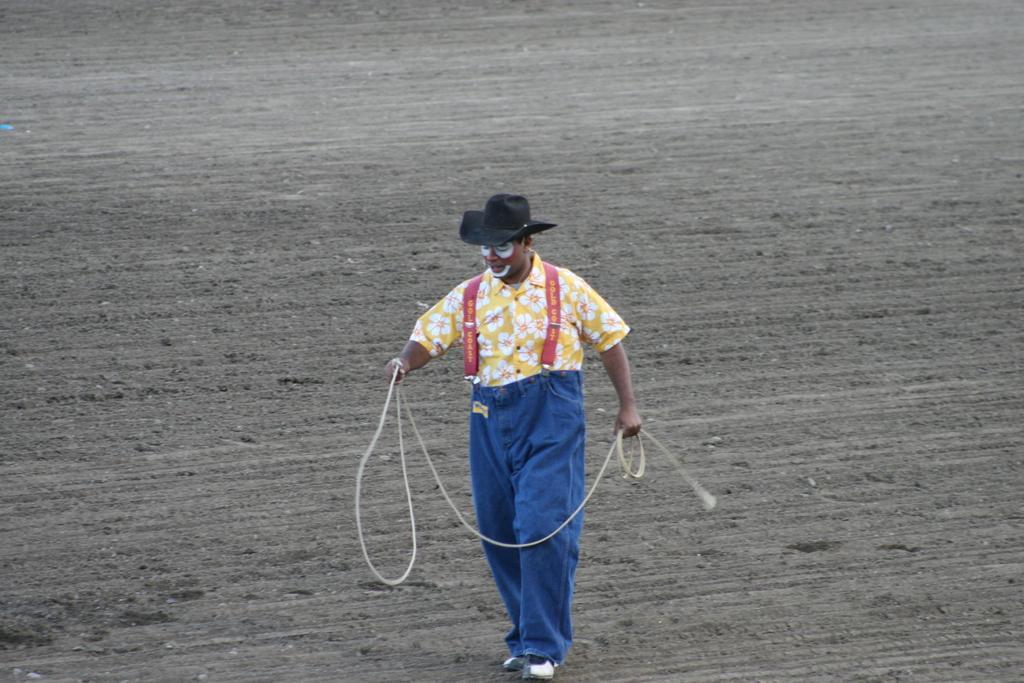Can you describe this image briefly? In this picture we can observe a person walking on the ground. He is wearing yellow and blue color dress. We can observe a black color cap on his head. He is holding a rope in his hand. In the background we can observe an open land. 